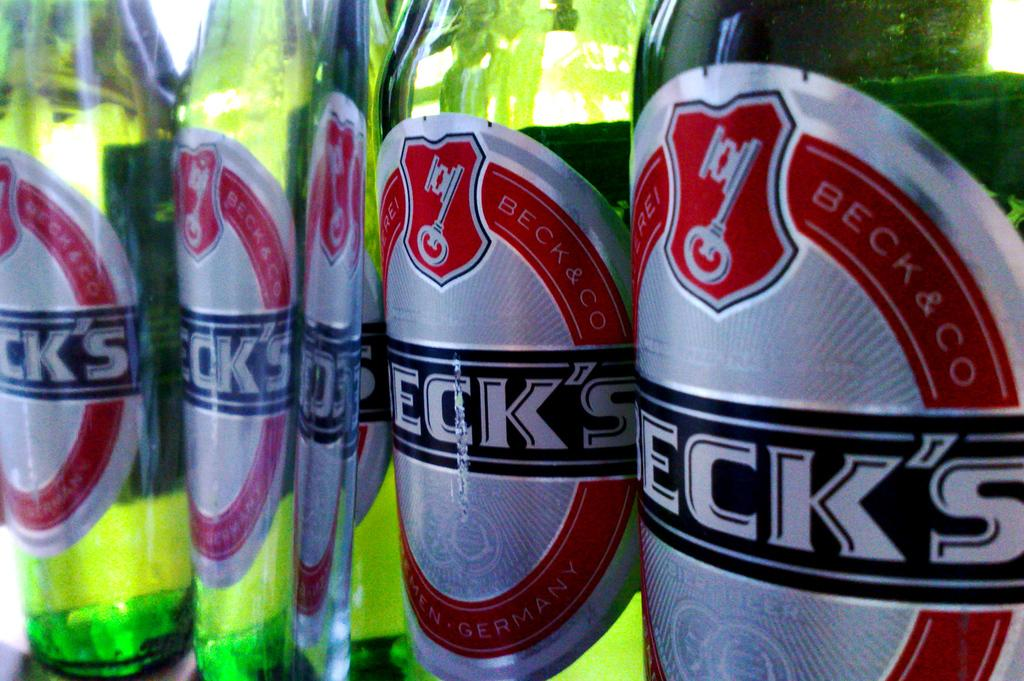Provide a one-sentence caption for the provided image. Bottles of beck's beer are all stood next to each other. 